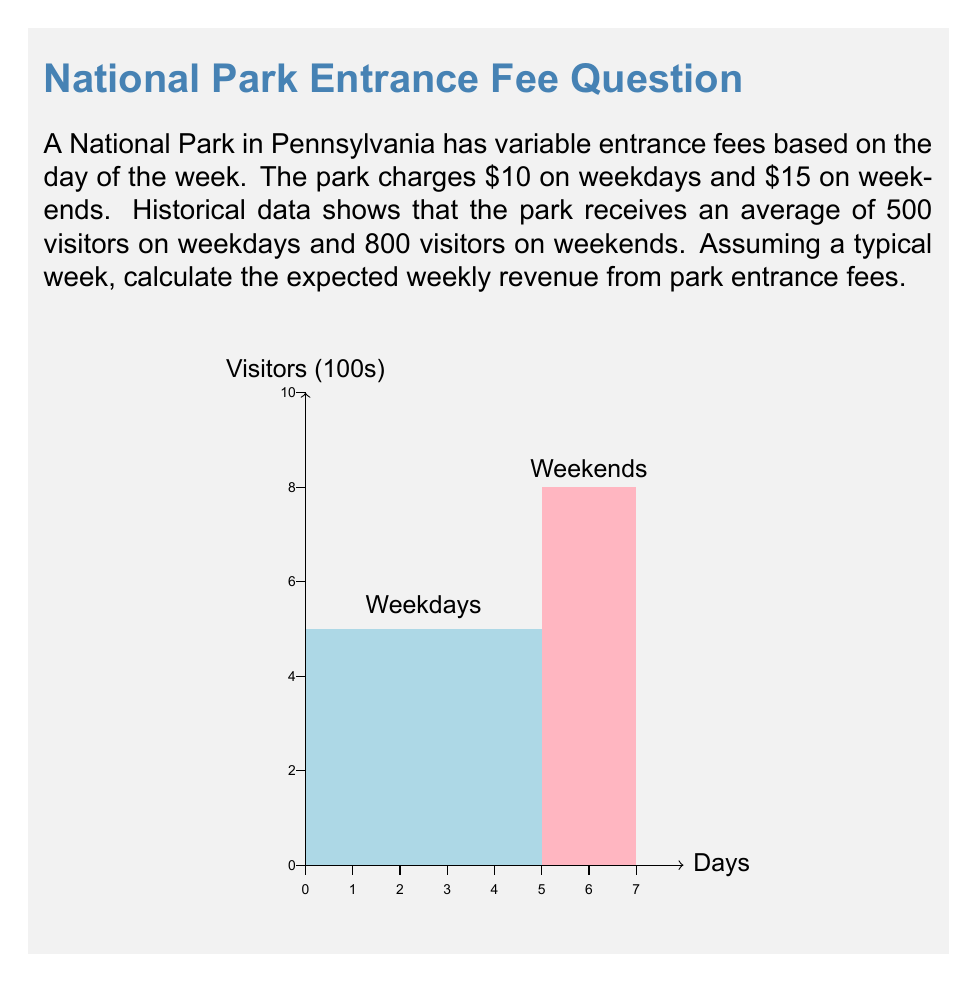Show me your answer to this math problem. To calculate the expected weekly revenue, we need to consider both weekdays and weekends separately:

1. Weekday Revenue:
   - Number of weekdays: 5
   - Fee per visitor: $10
   - Average visitors per weekday: 500
   - Weekday revenue: $5 \times 10 \times 500 = \$25,000$

2. Weekend Revenue:
   - Number of weekend days: 2
   - Fee per visitor: $15
   - Average visitors per weekend day: 800
   - Weekend revenue: $2 \times 15 \times 800 = \$24,000$

3. Total Weekly Revenue:
   Expected weekly revenue = Weekday revenue + Weekend revenue
   $$\text{Expected weekly revenue} = \$25,000 + \$24,000 = \$49,000$$

Therefore, the expected weekly revenue from park entrance fees is $49,000.
Answer: $49,000 